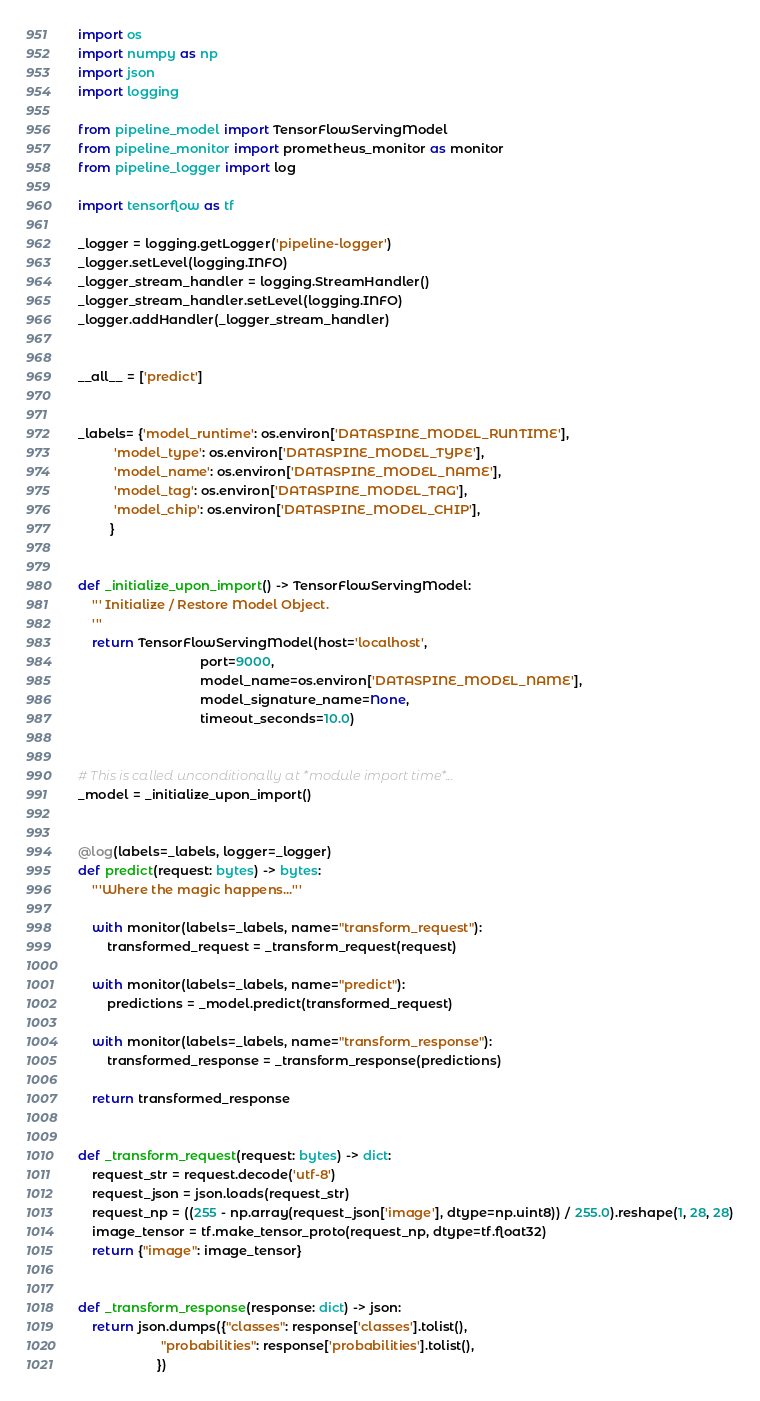<code> <loc_0><loc_0><loc_500><loc_500><_Python_>import os
import numpy as np
import json
import logging

from pipeline_model import TensorFlowServingModel
from pipeline_monitor import prometheus_monitor as monitor
from pipeline_logger import log

import tensorflow as tf

_logger = logging.getLogger('pipeline-logger')
_logger.setLevel(logging.INFO)
_logger_stream_handler = logging.StreamHandler()
_logger_stream_handler.setLevel(logging.INFO)
_logger.addHandler(_logger_stream_handler)


__all__ = ['predict']


_labels= {'model_runtime': os.environ['DATASPINE_MODEL_RUNTIME'],
          'model_type': os.environ['DATASPINE_MODEL_TYPE'],
          'model_name': os.environ['DATASPINE_MODEL_NAME'],
          'model_tag': os.environ['DATASPINE_MODEL_TAG'],
          'model_chip': os.environ['DATASPINE_MODEL_CHIP'],
         }


def _initialize_upon_import() -> TensorFlowServingModel:
    ''' Initialize / Restore Model Object.
    '''
    return TensorFlowServingModel(host='localhost',
                                  port=9000,
                                  model_name=os.environ['DATASPINE_MODEL_NAME'],
                                  model_signature_name=None,
                                  timeout_seconds=10.0)


# This is called unconditionally at *module import time*...
_model = _initialize_upon_import()


@log(labels=_labels, logger=_logger)
def predict(request: bytes) -> bytes:
    '''Where the magic happens...'''

    with monitor(labels=_labels, name="transform_request"):
        transformed_request = _transform_request(request)

    with monitor(labels=_labels, name="predict"):
        predictions = _model.predict(transformed_request)

    with monitor(labels=_labels, name="transform_response"):
        transformed_response = _transform_response(predictions)

    return transformed_response


def _transform_request(request: bytes) -> dict:
    request_str = request.decode('utf-8')
    request_json = json.loads(request_str)
    request_np = ((255 - np.array(request_json['image'], dtype=np.uint8)) / 255.0).reshape(1, 28, 28)
    image_tensor = tf.make_tensor_proto(request_np, dtype=tf.float32)
    return {"image": image_tensor}


def _transform_response(response: dict) -> json:
    return json.dumps({"classes": response['classes'].tolist(),
                       "probabilities": response['probabilities'].tolist(),
                      })
</code> 